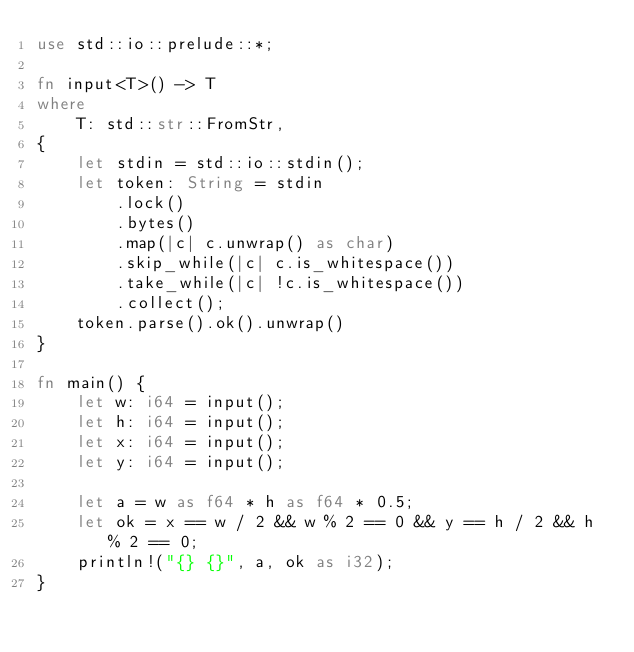Convert code to text. <code><loc_0><loc_0><loc_500><loc_500><_Rust_>use std::io::prelude::*;

fn input<T>() -> T
where
    T: std::str::FromStr,
{
    let stdin = std::io::stdin();
    let token: String = stdin
        .lock()
        .bytes()
        .map(|c| c.unwrap() as char)
        .skip_while(|c| c.is_whitespace())
        .take_while(|c| !c.is_whitespace())
        .collect();
    token.parse().ok().unwrap()
}

fn main() {
    let w: i64 = input();
    let h: i64 = input();
    let x: i64 = input();
    let y: i64 = input();

    let a = w as f64 * h as f64 * 0.5;
    let ok = x == w / 2 && w % 2 == 0 && y == h / 2 && h % 2 == 0;
    println!("{} {}", a, ok as i32);
}
</code> 